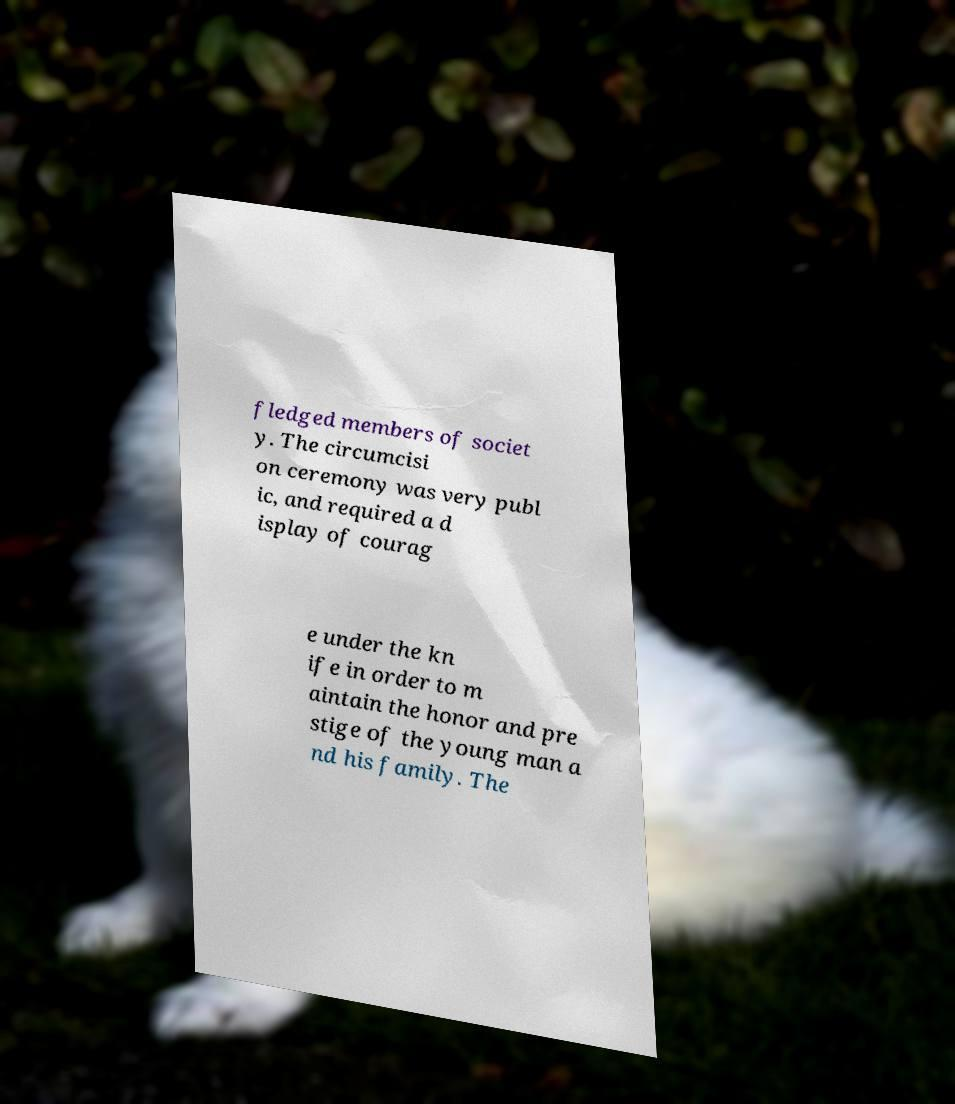For documentation purposes, I need the text within this image transcribed. Could you provide that? fledged members of societ y. The circumcisi on ceremony was very publ ic, and required a d isplay of courag e under the kn ife in order to m aintain the honor and pre stige of the young man a nd his family. The 